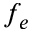Convert formula to latex. <formula><loc_0><loc_0><loc_500><loc_500>f _ { e }</formula> 